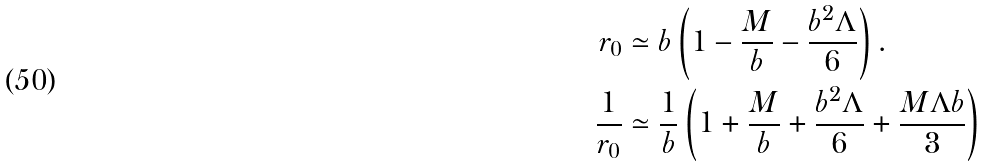Convert formula to latex. <formula><loc_0><loc_0><loc_500><loc_500>r _ { 0 } & \simeq b \left ( 1 - \frac { M } { b } - \frac { b ^ { 2 } \Lambda } { 6 } \right ) . \\ \frac { 1 } { r _ { 0 } } & \simeq \frac { 1 } { b } \left ( 1 + \frac { M } { b } + \frac { b ^ { 2 } \Lambda } { 6 } + \frac { M \Lambda b } { 3 } \right )</formula> 